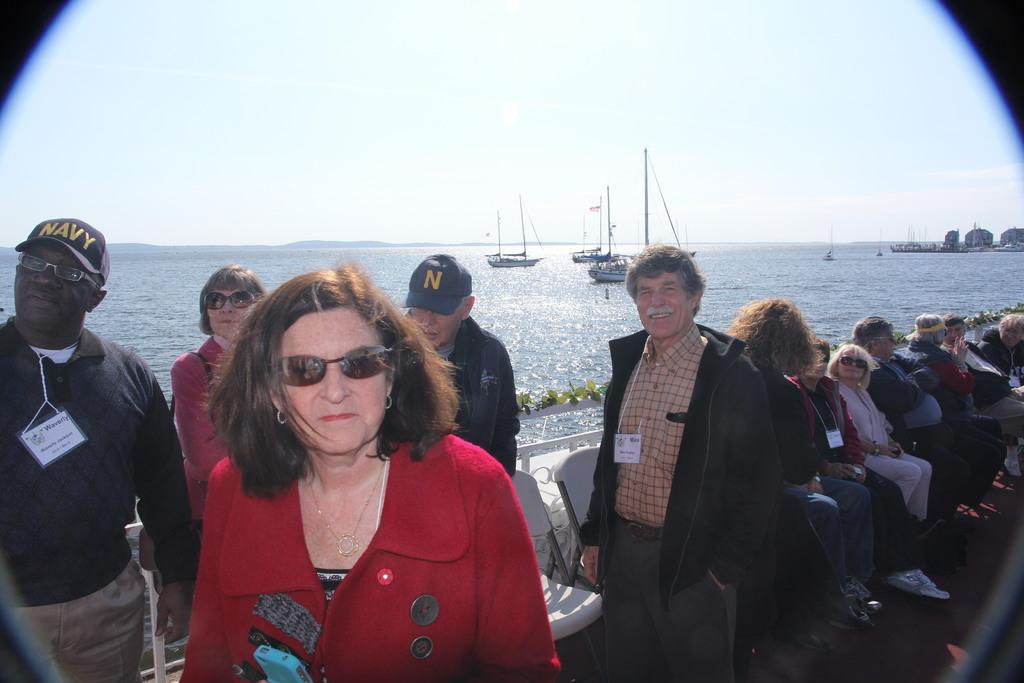What are the people in the image doing? There are people sitting on chairs and some people are standing in the image. What can be seen in the background of the image? There is an ocean in the background of the image. What is the condition of the sky in the image? The sky is clear in the image. How many oranges are being held by the cows in the image? There are no cows or oranges present in the image. What type of wrist accessory is visible on the people in the image? There is no wrist accessory visible on the people in the image. 